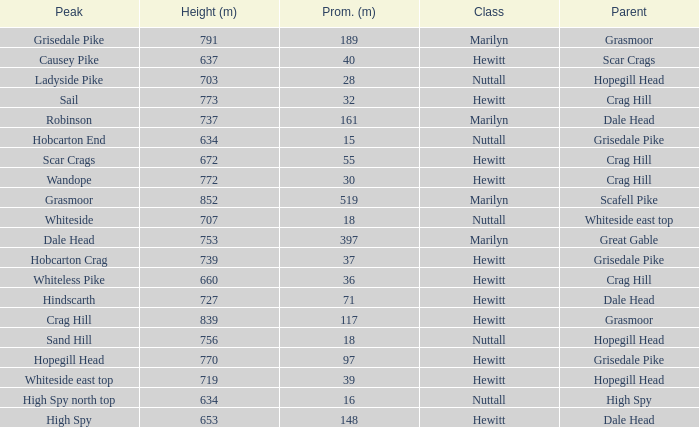What is the lowest height for Parent grasmoor when it has a Prom larger than 117? 791.0. 